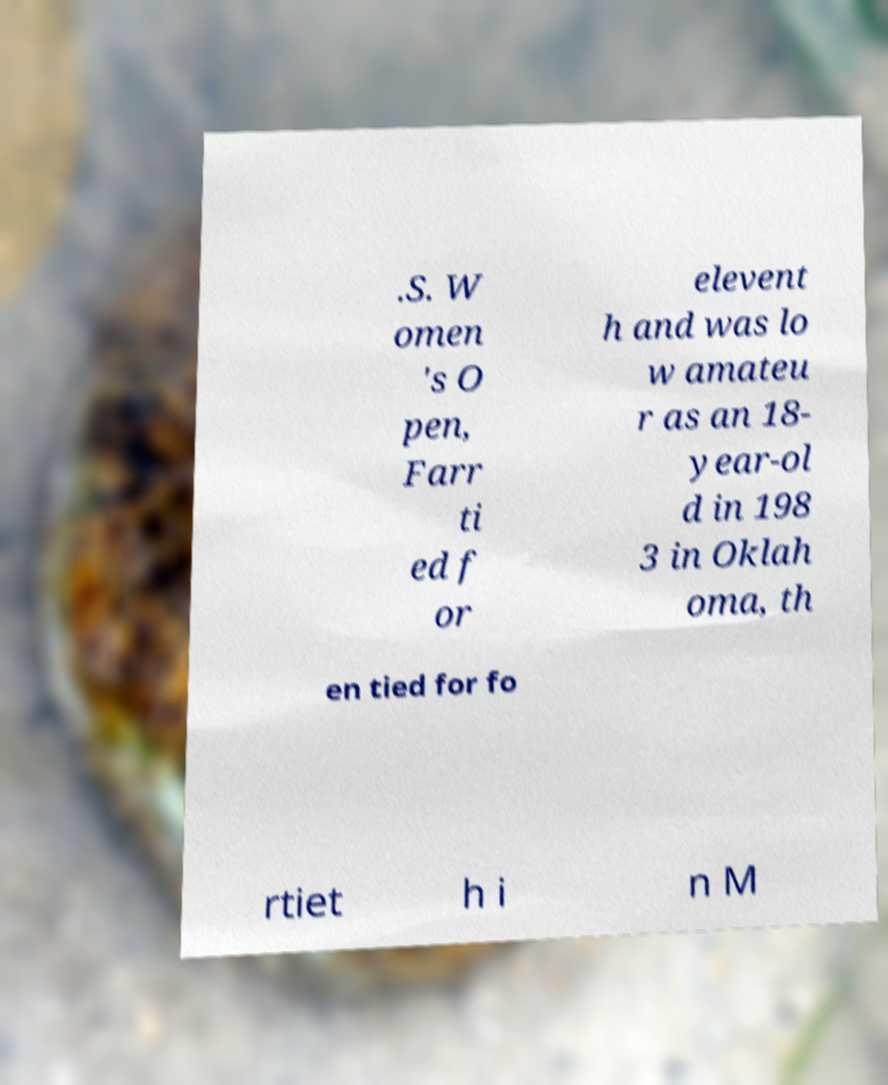Could you assist in decoding the text presented in this image and type it out clearly? .S. W omen 's O pen, Farr ti ed f or elevent h and was lo w amateu r as an 18- year-ol d in 198 3 in Oklah oma, th en tied for fo rtiet h i n M 